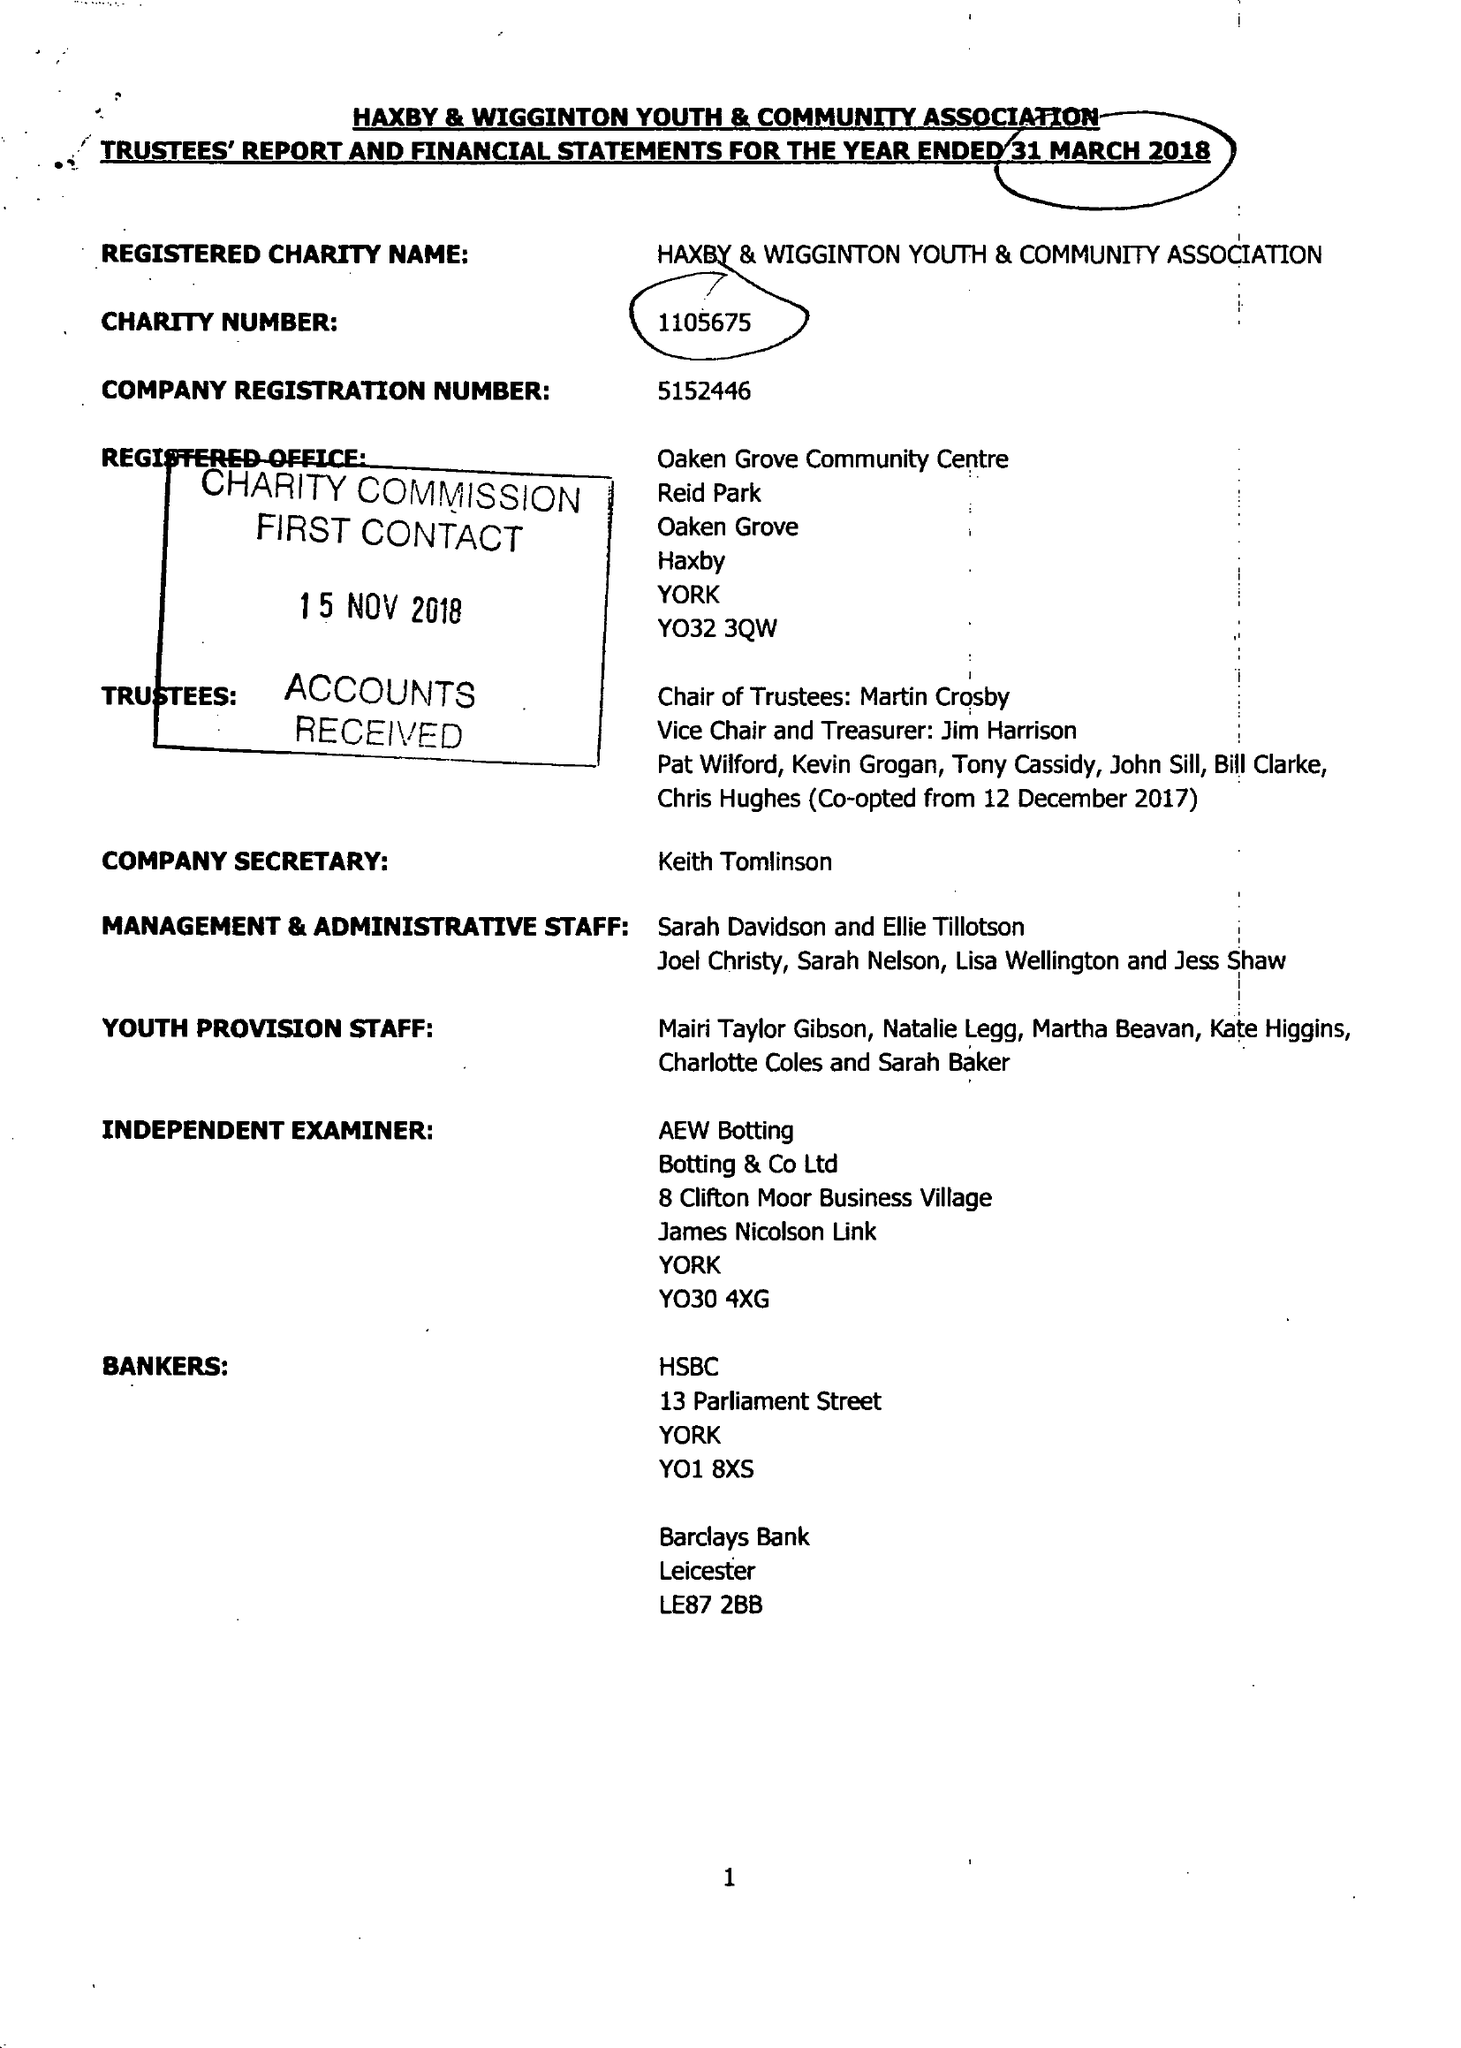What is the value for the charity_name?
Answer the question using a single word or phrase. Haxby and Wigginton Youth and Community Association 